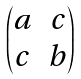Convert formula to latex. <formula><loc_0><loc_0><loc_500><loc_500>\begin{pmatrix} a & c \\ c & b \\ \end{pmatrix}</formula> 